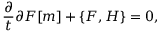<formula> <loc_0><loc_0><loc_500><loc_500>\frac { \partial } { t } { \partial F } [ m ] + \left \{ F , H \right \} = 0 ,</formula> 